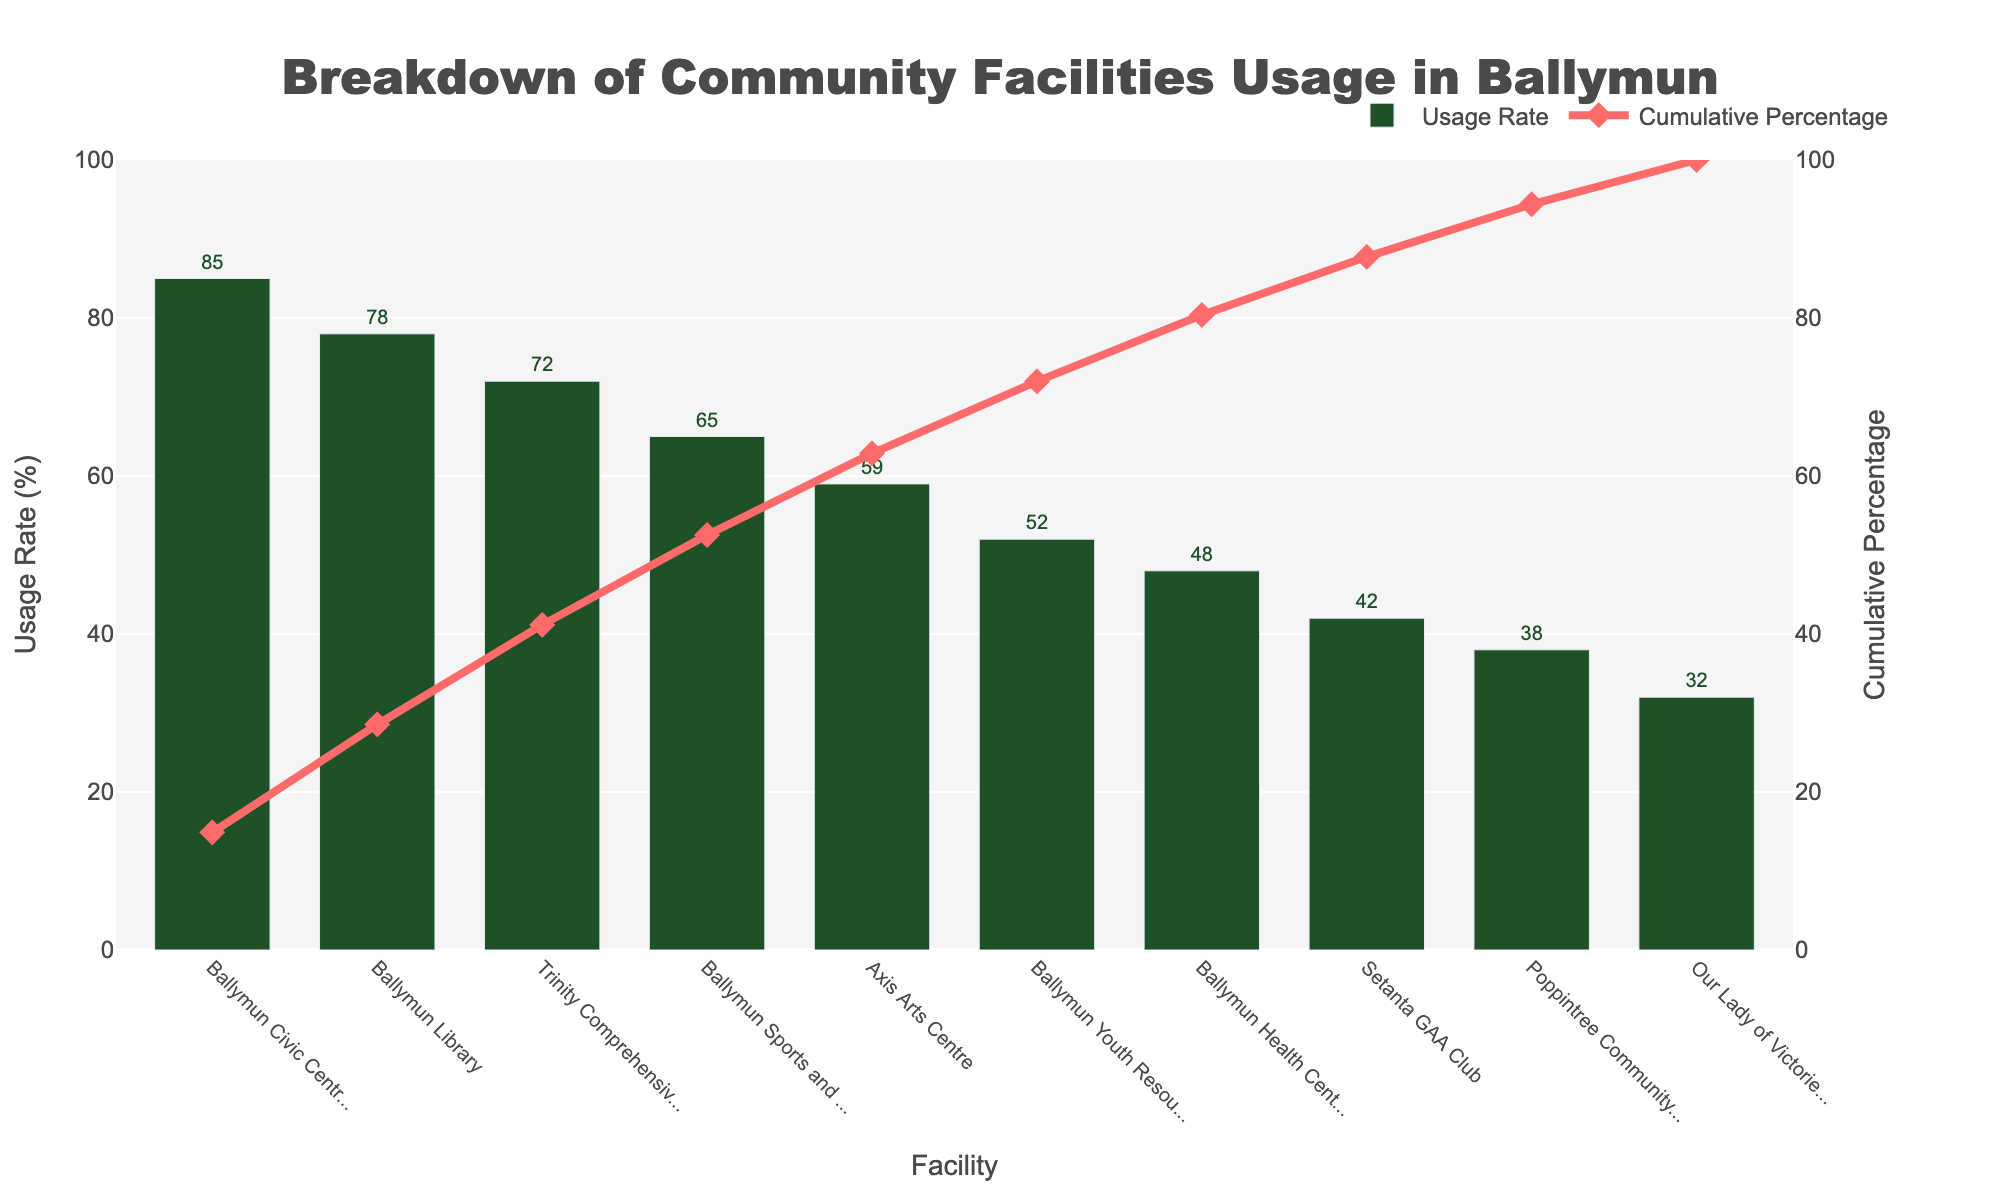What is the usage rate of Ballymun Civic Centre? Look at the bar labeled Ballymun Civic Centre on the chart and identify the value above it
Answer: 85% Which facility has the lowest usage rate? Identify the bar with the shortest height in the chart
Answer: Our Lady of Victories Church How many facilities have a usage rate higher than 60%? Count the number of bars that have a value above 60% on the y-axis
Answer: 5 What is the cumulative percentage after including Ballymun Health Centre? Find Ballymun Health Centre on the x-axis and trace the point on the cumulative percentage line
Answer: 79% Compare the usage rates of Ballymun Sports and Fitness Centre and Axis Arts Centre. Which one is greater? Look at the height of the bars corresponding to Ballymun Sports and Fitness Centre and Axis Arts Centre and compare the values
Answer: Ballymun Sports and Fitness Centre What is the combined usage rate of Poppintree Community Sports Centre and Setanta GAA Club? Add the usage rates of Poppintree Community Sports Centre (38%) and Setanta GAA Club (42%)
Answer: 80% Which facility is the third most used according to the chart? Identify the third highest bar in height
Answer: Trinity Comprehensive School Do more than half of the facilities have a usage rate above 50%? Count the facilities with usage rates higher than 50% and see if they are more than half of the total facilities (i.e., 5)
Answer: Yes What is the usage rate difference between the highest and lowest usage rate facilities? Subtract the lowest usage rate (32%) from the highest usage rate (85%)
Answer: 53% At which facility does the cumulative usage percentage first exceed 50%? Trace the cumulative percentage line until it exceeds 50% and note the corresponding facility
Answer: Ballymun Library 